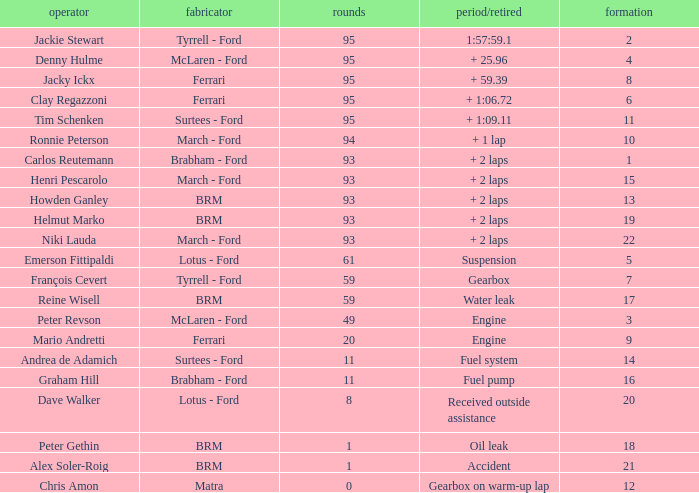What is the lowest grid with matra as constructor? 12.0. 